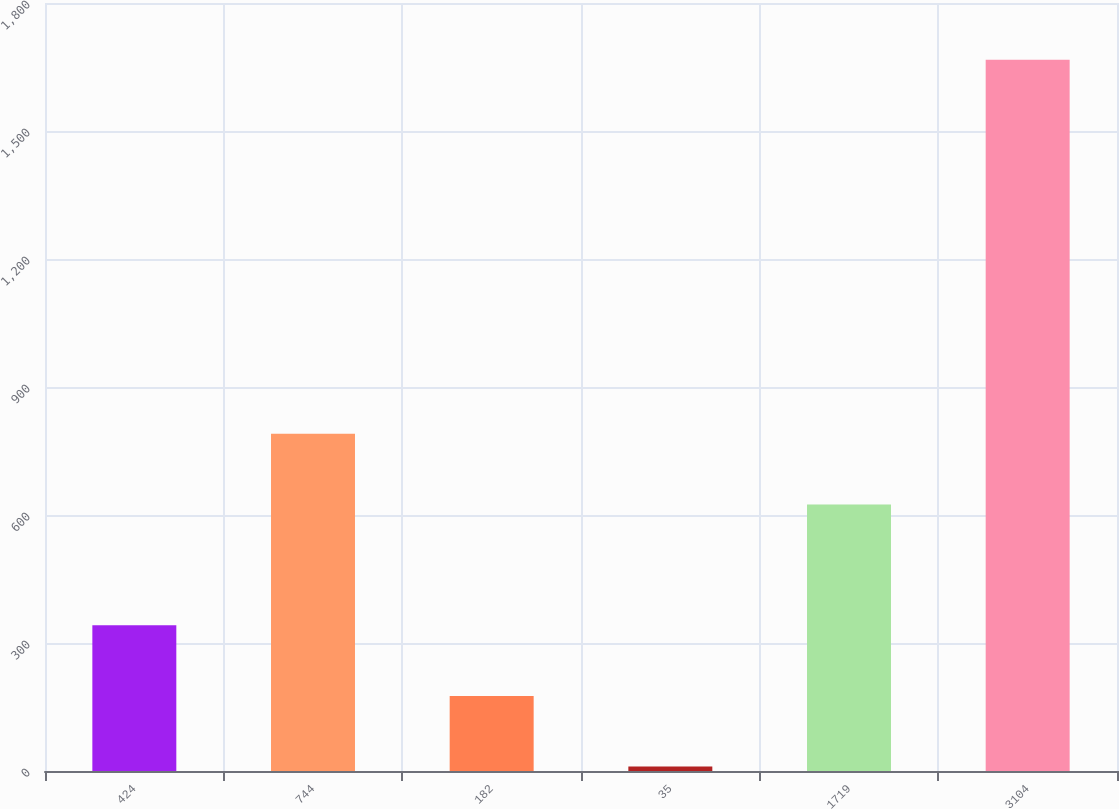Convert chart to OTSL. <chart><loc_0><loc_0><loc_500><loc_500><bar_chart><fcel>424<fcel>744<fcel>182<fcel>35<fcel>1719<fcel>3104<nl><fcel>341.66<fcel>790.33<fcel>176.03<fcel>10.4<fcel>624.7<fcel>1666.7<nl></chart> 